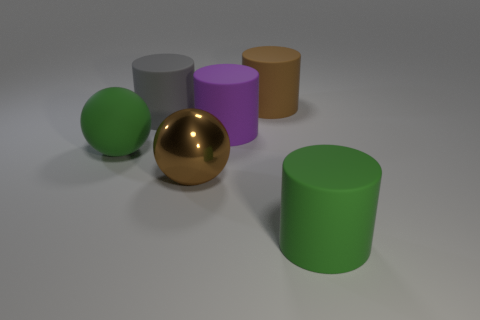Subtract all large gray rubber cylinders. How many cylinders are left? 3 Subtract all purple cylinders. How many cylinders are left? 3 Subtract 1 cylinders. How many cylinders are left? 3 Add 2 brown spheres. How many objects exist? 8 Subtract all brown cylinders. Subtract all yellow blocks. How many cylinders are left? 3 Subtract all balls. How many objects are left? 4 Subtract all small gray blocks. Subtract all big brown matte cylinders. How many objects are left? 5 Add 3 balls. How many balls are left? 5 Add 5 small yellow objects. How many small yellow objects exist? 5 Subtract 0 yellow cylinders. How many objects are left? 6 